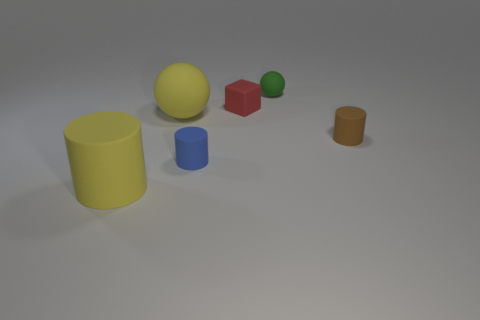Add 2 tiny cyan rubber cylinders. How many objects exist? 8 Subtract all cubes. How many objects are left? 5 Add 6 big yellow rubber spheres. How many big yellow rubber spheres exist? 7 Subtract 0 cyan blocks. How many objects are left? 6 Subtract all tiny rubber spheres. Subtract all small red blocks. How many objects are left? 4 Add 3 rubber cubes. How many rubber cubes are left? 4 